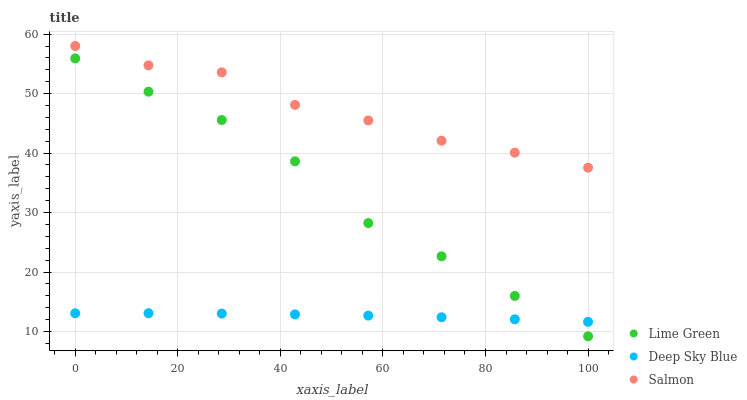Does Deep Sky Blue have the minimum area under the curve?
Answer yes or no. Yes. Does Salmon have the maximum area under the curve?
Answer yes or no. Yes. Does Lime Green have the minimum area under the curve?
Answer yes or no. No. Does Lime Green have the maximum area under the curve?
Answer yes or no. No. Is Deep Sky Blue the smoothest?
Answer yes or no. Yes. Is Lime Green the roughest?
Answer yes or no. Yes. Is Lime Green the smoothest?
Answer yes or no. No. Is Deep Sky Blue the roughest?
Answer yes or no. No. Does Lime Green have the lowest value?
Answer yes or no. Yes. Does Deep Sky Blue have the lowest value?
Answer yes or no. No. Does Salmon have the highest value?
Answer yes or no. Yes. Does Lime Green have the highest value?
Answer yes or no. No. Is Deep Sky Blue less than Salmon?
Answer yes or no. Yes. Is Salmon greater than Lime Green?
Answer yes or no. Yes. Does Deep Sky Blue intersect Lime Green?
Answer yes or no. Yes. Is Deep Sky Blue less than Lime Green?
Answer yes or no. No. Is Deep Sky Blue greater than Lime Green?
Answer yes or no. No. Does Deep Sky Blue intersect Salmon?
Answer yes or no. No. 